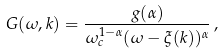Convert formula to latex. <formula><loc_0><loc_0><loc_500><loc_500>G ( \omega , { k } ) = \frac { g ( \alpha ) } { \omega _ { c } ^ { 1 - \alpha } ( \omega - \xi ( { k } ) ) ^ { \alpha } } \, ,</formula> 